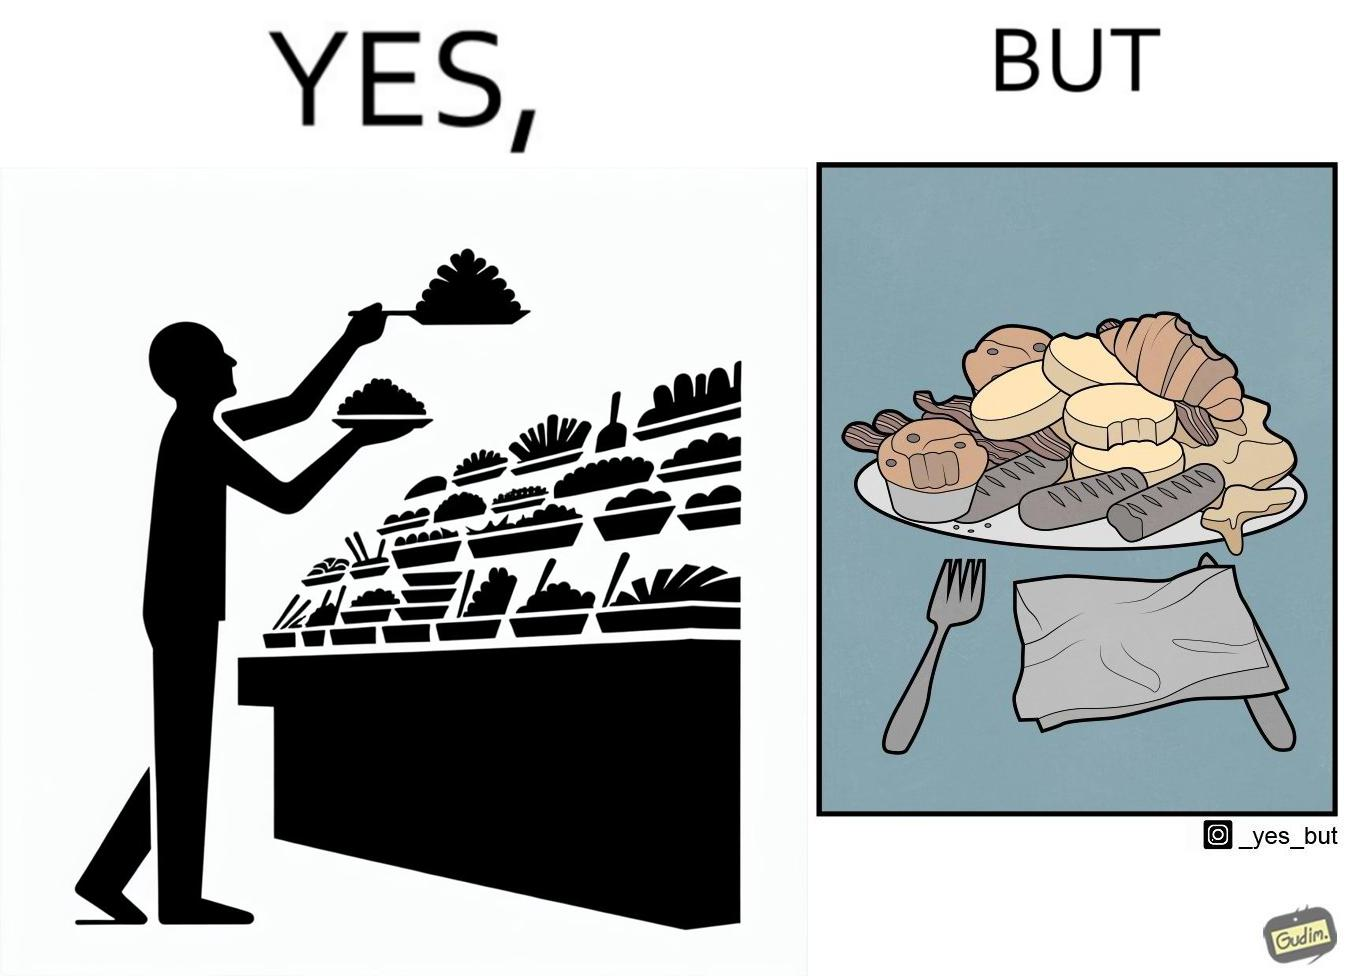Would you classify this image as satirical? Yes, this image is satirical. 